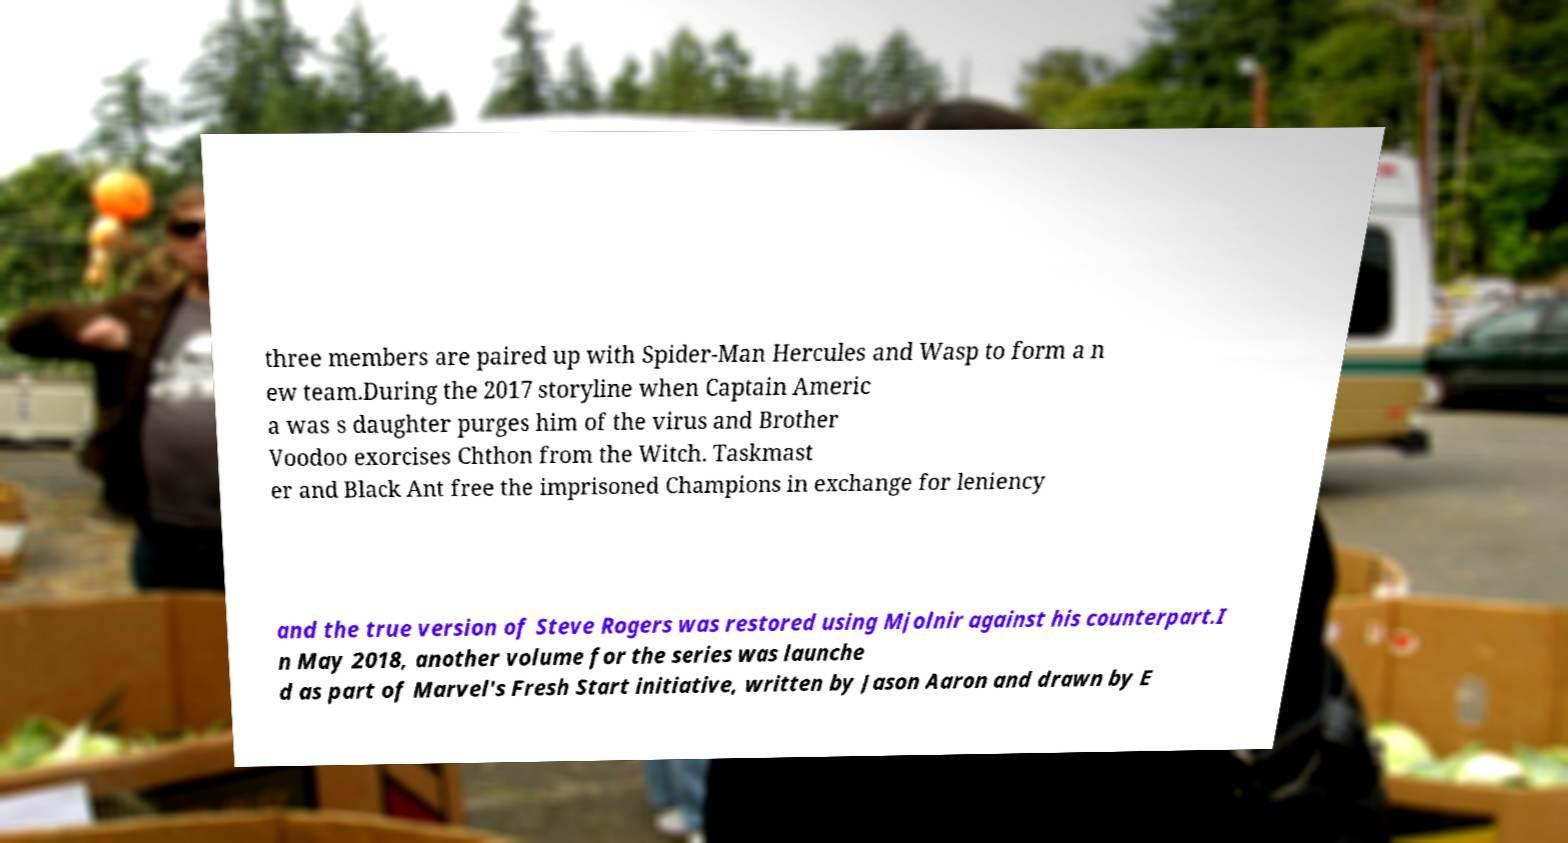Can you accurately transcribe the text from the provided image for me? three members are paired up with Spider-Man Hercules and Wasp to form a n ew team.During the 2017 storyline when Captain Americ a was s daughter purges him of the virus and Brother Voodoo exorcises Chthon from the Witch. Taskmast er and Black Ant free the imprisoned Champions in exchange for leniency and the true version of Steve Rogers was restored using Mjolnir against his counterpart.I n May 2018, another volume for the series was launche d as part of Marvel's Fresh Start initiative, written by Jason Aaron and drawn by E 